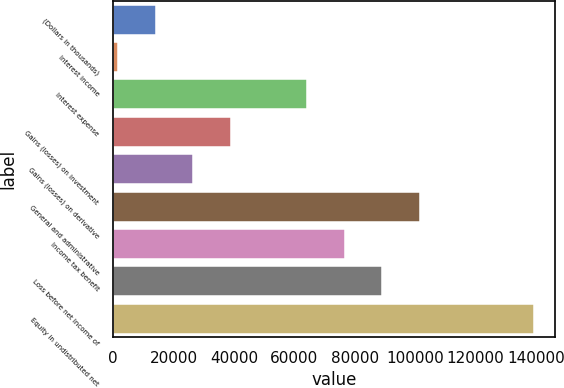Convert chart to OTSL. <chart><loc_0><loc_0><loc_500><loc_500><bar_chart><fcel>(Dollars in thousands)<fcel>Interest income<fcel>Interest expense<fcel>Gains (losses) on investment<fcel>Gains (losses) on derivative<fcel>General and administrative<fcel>Income tax benefit<fcel>Loss before net income of<fcel>Equity in undistributed net<nl><fcel>14113.3<fcel>1603<fcel>64154.5<fcel>39133.9<fcel>26623.6<fcel>101685<fcel>76664.8<fcel>89175.1<fcel>139216<nl></chart> 